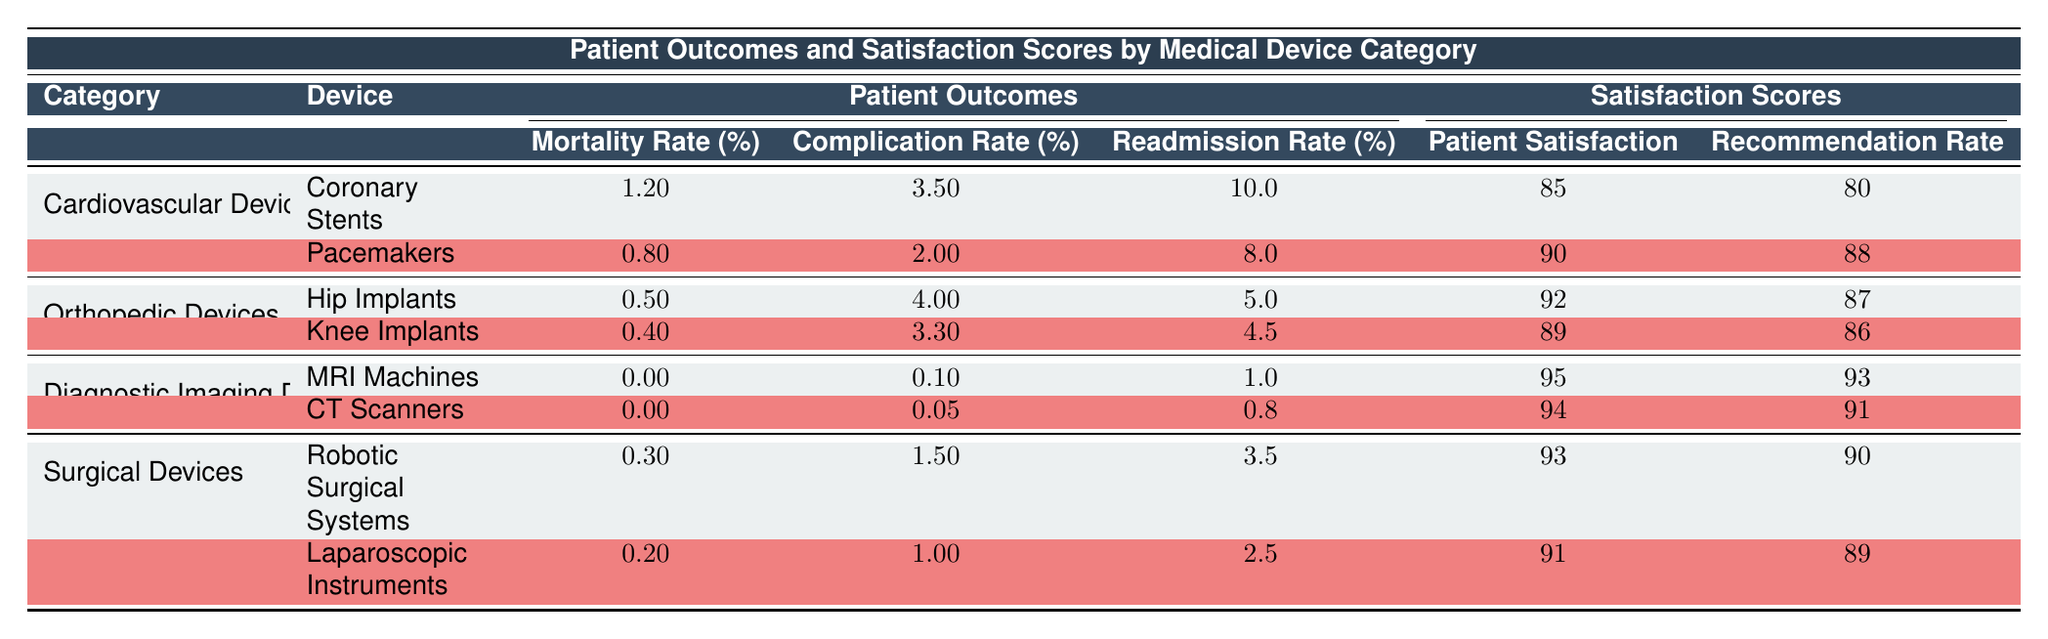What is the mortality rate for Pacemakers? The table lists the patient outcomes for Pacemakers under the Cardiovascular Devices category, showing the Mortality Rate as 0.8%.
Answer: 0.8% Which device has the highest patient satisfaction score among Orthopedic Devices? In the Orthopedic Devices category, Hip Implants have a Patient Satisfaction score of 92, and Knee Implants have a score of 89. Therefore, Hip Implants have the highest patient satisfaction score.
Answer: Hip Implants What is the average readmission rate across all device categories? The readmission rates from the table are as follows: 10.0 (Coronary Stents), 8.0 (Pacemakers), 5.0 (Hip Implants), 4.5 (Knee Implants), 1.0 (MRI Machines), 0.8 (CT Scanners), 3.5 (Robotic Surgical Systems), and 2.5 (Laparoscopic Instruments). Adding these gives 10.0 + 8.0 + 5.0 + 4.5 + 1.0 + 0.8 + 3.5 + 2.5 = 35.3. Dividing by the number of devices (8) yields an average readmission rate of 4.4125%.
Answer: 4.41% Is the complication rate for Hip Implants lower than that for Coronary Stents? The complication rate for Hip Implants is 4.0%, while for Coronary Stents it is 3.5%. Since 4.0% is not lower than 3.5%, the statement is false.
Answer: No What is the difference in recommendation rate between Robotic Surgical Systems and Knee Implants? The recommendation rates are 90 for Robotic Surgical Systems and 86 for Knee Implants. The difference is 90 - 86 = 4.
Answer: 4 